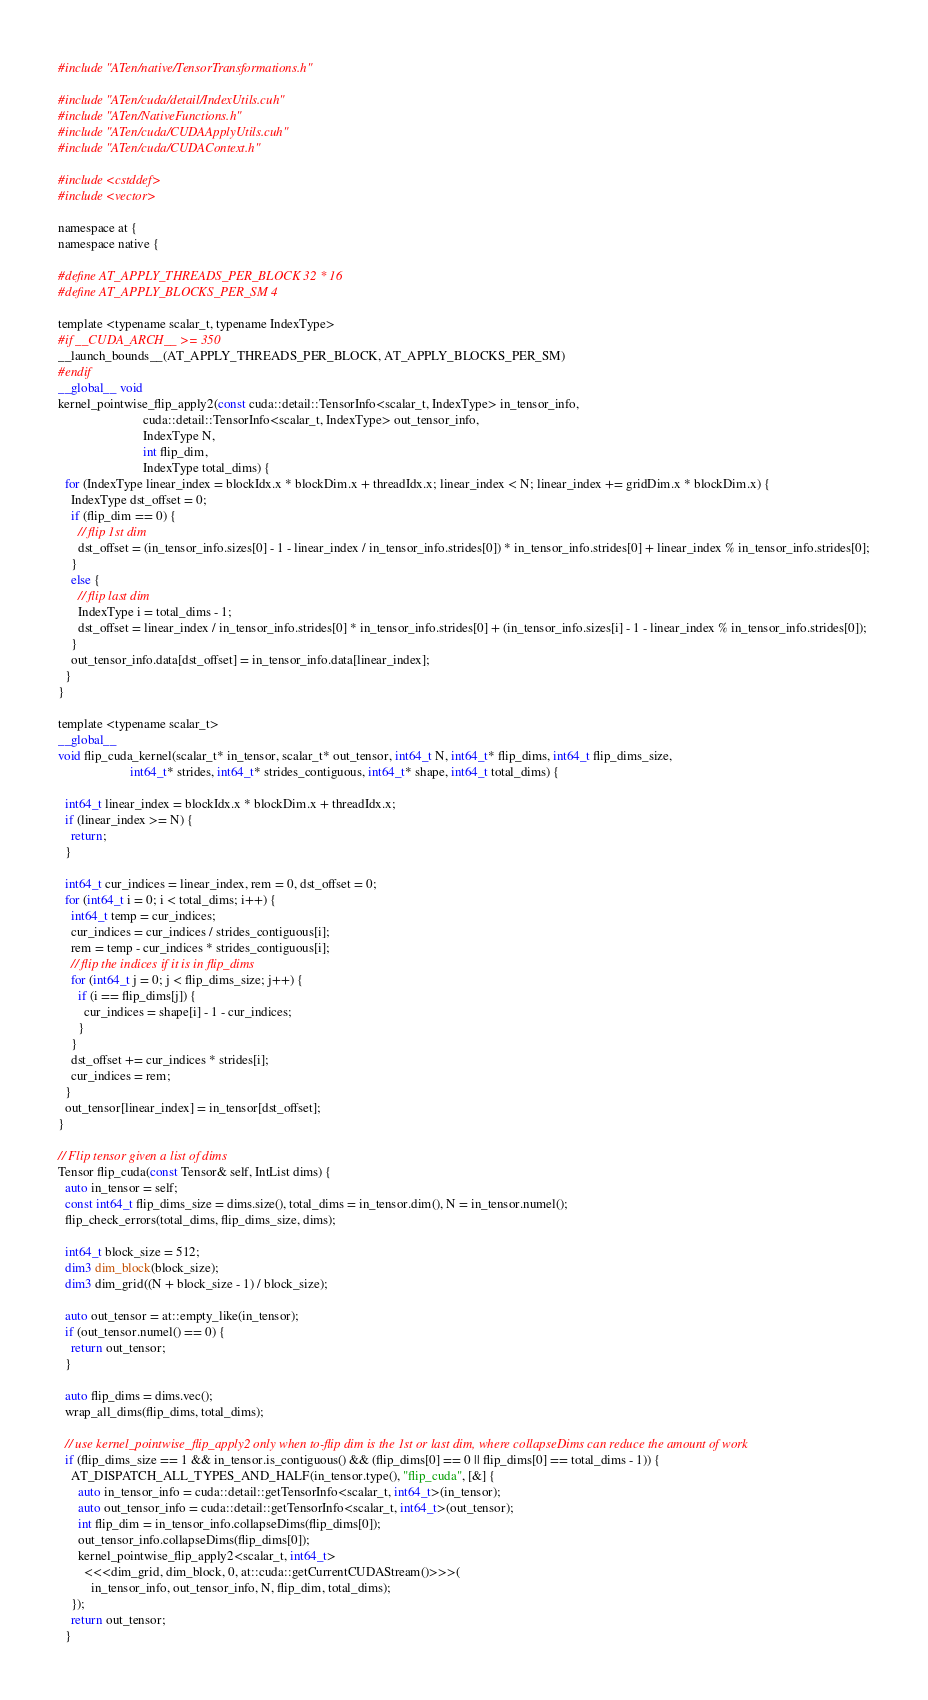<code> <loc_0><loc_0><loc_500><loc_500><_Cuda_>#include "ATen/native/TensorTransformations.h"

#include "ATen/cuda/detail/IndexUtils.cuh"
#include "ATen/NativeFunctions.h"
#include "ATen/cuda/CUDAApplyUtils.cuh"
#include "ATen/cuda/CUDAContext.h"

#include <cstddef>
#include <vector>

namespace at {
namespace native {

#define AT_APPLY_THREADS_PER_BLOCK 32 * 16
#define AT_APPLY_BLOCKS_PER_SM 4

template <typename scalar_t, typename IndexType>
#if __CUDA_ARCH__ >= 350
__launch_bounds__(AT_APPLY_THREADS_PER_BLOCK, AT_APPLY_BLOCKS_PER_SM)
#endif
__global__ void
kernel_pointwise_flip_apply2(const cuda::detail::TensorInfo<scalar_t, IndexType> in_tensor_info,
                          cuda::detail::TensorInfo<scalar_t, IndexType> out_tensor_info,
                          IndexType N,
                          int flip_dim,
                          IndexType total_dims) {
  for (IndexType linear_index = blockIdx.x * blockDim.x + threadIdx.x; linear_index < N; linear_index += gridDim.x * blockDim.x) {
    IndexType dst_offset = 0;
    if (flip_dim == 0) {
      // flip 1st dim
      dst_offset = (in_tensor_info.sizes[0] - 1 - linear_index / in_tensor_info.strides[0]) * in_tensor_info.strides[0] + linear_index % in_tensor_info.strides[0];
    }
    else {
      // flip last dim
      IndexType i = total_dims - 1;
      dst_offset = linear_index / in_tensor_info.strides[0] * in_tensor_info.strides[0] + (in_tensor_info.sizes[i] - 1 - linear_index % in_tensor_info.strides[0]);
    }
    out_tensor_info.data[dst_offset] = in_tensor_info.data[linear_index];
  }
}

template <typename scalar_t>
__global__
void flip_cuda_kernel(scalar_t* in_tensor, scalar_t* out_tensor, int64_t N, int64_t* flip_dims, int64_t flip_dims_size,
                      int64_t* strides, int64_t* strides_contiguous, int64_t* shape, int64_t total_dims) {

  int64_t linear_index = blockIdx.x * blockDim.x + threadIdx.x;
  if (linear_index >= N) {
    return;
  }

  int64_t cur_indices = linear_index, rem = 0, dst_offset = 0;
  for (int64_t i = 0; i < total_dims; i++) {
    int64_t temp = cur_indices;
    cur_indices = cur_indices / strides_contiguous[i];
    rem = temp - cur_indices * strides_contiguous[i];
    // flip the indices if it is in flip_dims
    for (int64_t j = 0; j < flip_dims_size; j++) {
      if (i == flip_dims[j]) {
        cur_indices = shape[i] - 1 - cur_indices;
      }
    }
    dst_offset += cur_indices * strides[i];
    cur_indices = rem;
  }
  out_tensor[linear_index] = in_tensor[dst_offset];
}

// Flip tensor given a list of dims
Tensor flip_cuda(const Tensor& self, IntList dims) {
  auto in_tensor = self;
  const int64_t flip_dims_size = dims.size(), total_dims = in_tensor.dim(), N = in_tensor.numel();
  flip_check_errors(total_dims, flip_dims_size, dims);

  int64_t block_size = 512;
  dim3 dim_block(block_size);
  dim3 dim_grid((N + block_size - 1) / block_size);

  auto out_tensor = at::empty_like(in_tensor);
  if (out_tensor.numel() == 0) {
    return out_tensor;
  }

  auto flip_dims = dims.vec();
  wrap_all_dims(flip_dims, total_dims);

  // use kernel_pointwise_flip_apply2 only when to-flip dim is the 1st or last dim, where collapseDims can reduce the amount of work
  if (flip_dims_size == 1 && in_tensor.is_contiguous() && (flip_dims[0] == 0 || flip_dims[0] == total_dims - 1)) {
    AT_DISPATCH_ALL_TYPES_AND_HALF(in_tensor.type(), "flip_cuda", [&] {
      auto in_tensor_info = cuda::detail::getTensorInfo<scalar_t, int64_t>(in_tensor);
      auto out_tensor_info = cuda::detail::getTensorInfo<scalar_t, int64_t>(out_tensor);
      int flip_dim = in_tensor_info.collapseDims(flip_dims[0]);
      out_tensor_info.collapseDims(flip_dims[0]);
      kernel_pointwise_flip_apply2<scalar_t, int64_t>
        <<<dim_grid, dim_block, 0, at::cuda::getCurrentCUDAStream()>>>(
          in_tensor_info, out_tensor_info, N, flip_dim, total_dims);
    });
    return out_tensor;
  }
</code> 